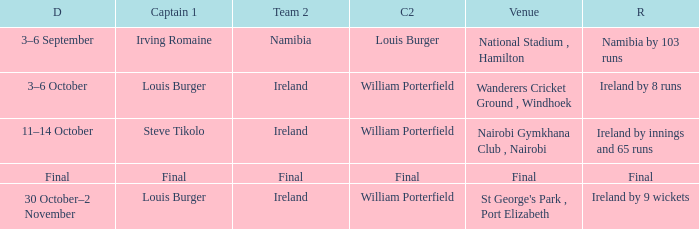Which Team 2 has a Captain 1 of final? Final. 